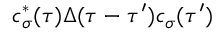<formula> <loc_0><loc_0><loc_500><loc_500>c _ { \sigma } ^ { * } ( \tau ) \Delta ( \tau - \tau ^ { \prime } ) c _ { \sigma } ( \tau ^ { \prime } )</formula> 